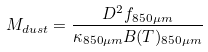<formula> <loc_0><loc_0><loc_500><loc_500>M _ { d u s t } = \frac { D ^ { 2 } f _ { 8 5 0 \mu m } } { \kappa _ { 8 5 0 \mu m } B ( T ) _ { 8 5 0 \mu m } }</formula> 